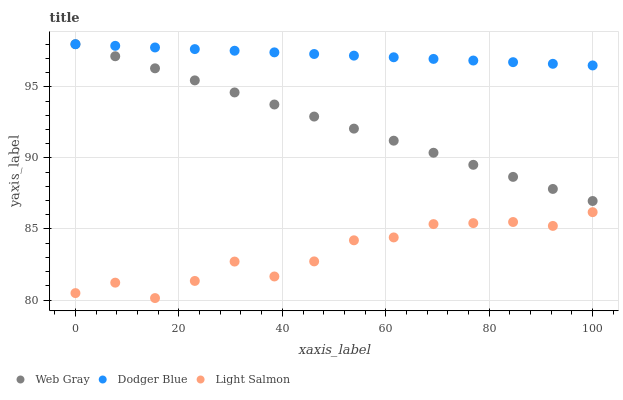Does Light Salmon have the minimum area under the curve?
Answer yes or no. Yes. Does Dodger Blue have the maximum area under the curve?
Answer yes or no. Yes. Does Web Gray have the minimum area under the curve?
Answer yes or no. No. Does Web Gray have the maximum area under the curve?
Answer yes or no. No. Is Dodger Blue the smoothest?
Answer yes or no. Yes. Is Light Salmon the roughest?
Answer yes or no. Yes. Is Web Gray the smoothest?
Answer yes or no. No. Is Web Gray the roughest?
Answer yes or no. No. Does Light Salmon have the lowest value?
Answer yes or no. Yes. Does Web Gray have the lowest value?
Answer yes or no. No. Does Dodger Blue have the highest value?
Answer yes or no. Yes. Is Light Salmon less than Web Gray?
Answer yes or no. Yes. Is Dodger Blue greater than Light Salmon?
Answer yes or no. Yes. Does Dodger Blue intersect Web Gray?
Answer yes or no. Yes. Is Dodger Blue less than Web Gray?
Answer yes or no. No. Is Dodger Blue greater than Web Gray?
Answer yes or no. No. Does Light Salmon intersect Web Gray?
Answer yes or no. No. 